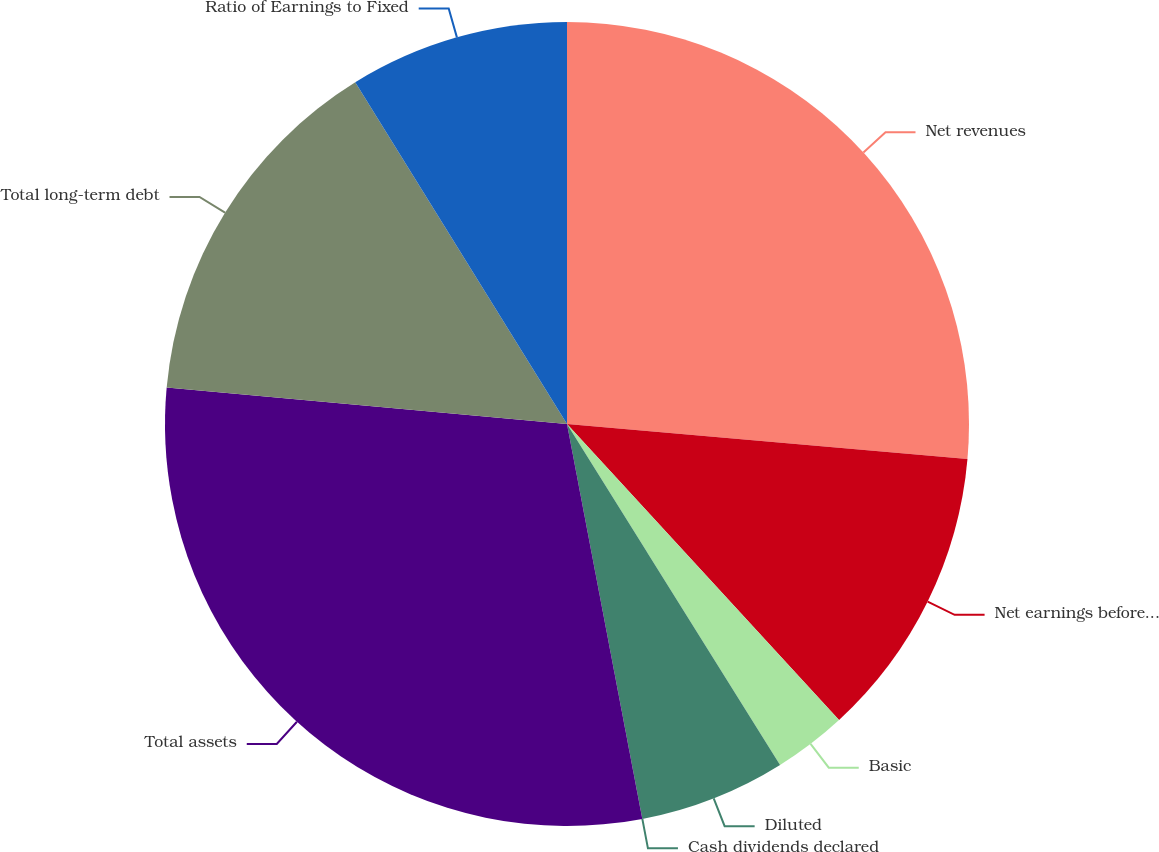Convert chart to OTSL. <chart><loc_0><loc_0><loc_500><loc_500><pie_chart><fcel>Net revenues<fcel>Net earnings before cumulative<fcel>Basic<fcel>Diluted<fcel>Cash dividends declared<fcel>Total assets<fcel>Total long-term debt<fcel>Ratio of Earnings to Fixed<nl><fcel>26.39%<fcel>11.78%<fcel>2.94%<fcel>5.89%<fcel>0.0%<fcel>29.45%<fcel>14.72%<fcel>8.83%<nl></chart> 